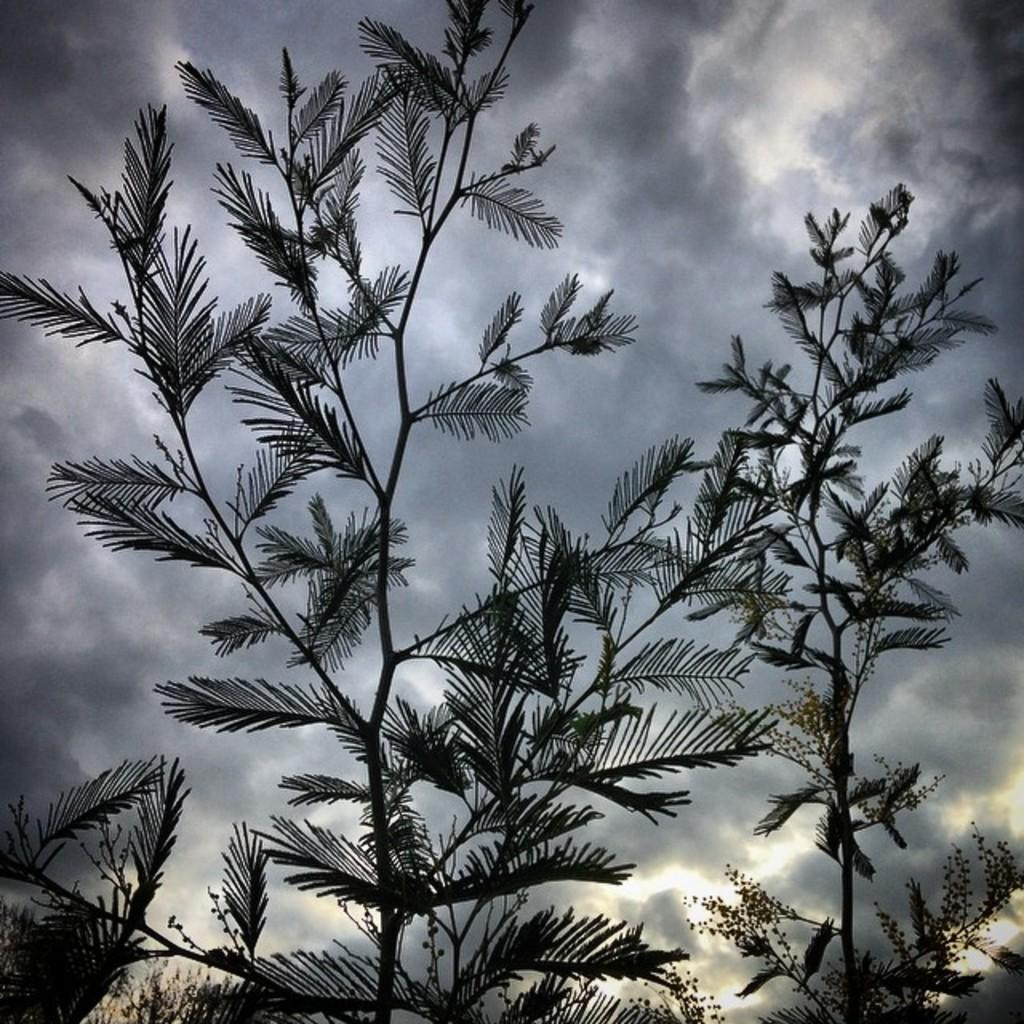What type of vegetation can be seen in the image? There are trees in the image. What is visible in the background of the image? The sky is visible in the background of the image. What can be observed in the sky? Clouds are present in the sky. What type of skin condition can be seen on the trees in the image? There is no mention of any skin condition on the trees in the image. The trees appear to be healthy and normal. 